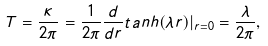<formula> <loc_0><loc_0><loc_500><loc_500>T = \frac { \kappa } { 2 \pi } = \frac { 1 } { 2 \pi } \frac { d } { d r } t a n h ( \lambda r ) | _ { r = 0 } = \frac { \lambda } { 2 \pi } ,</formula> 